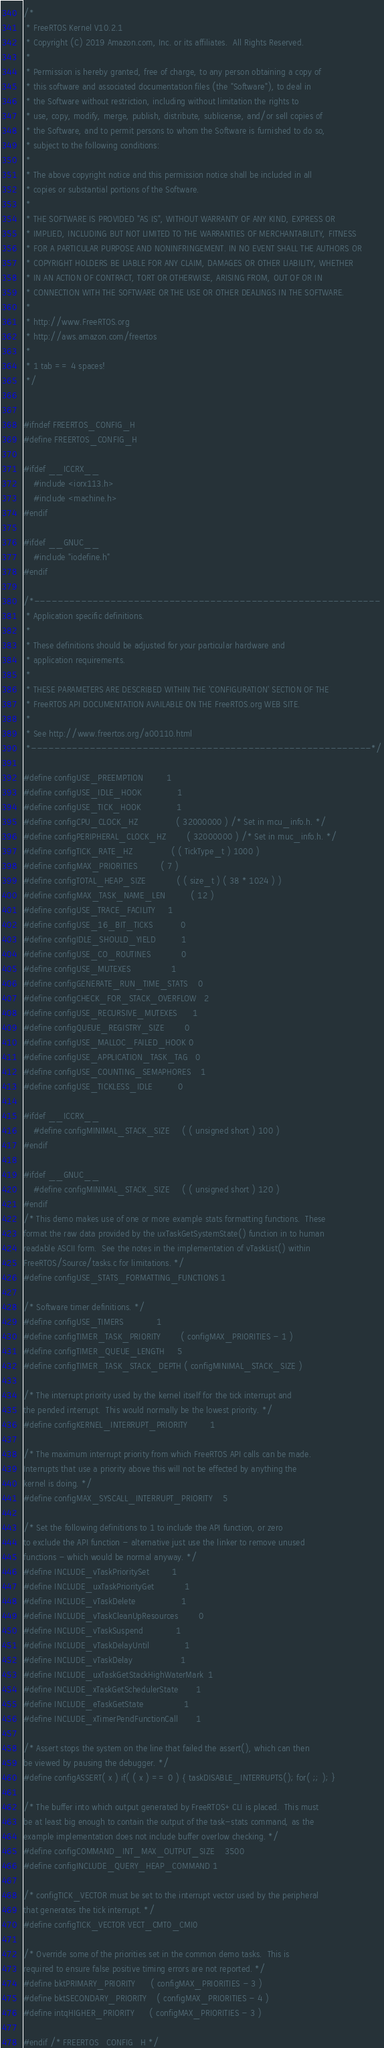<code> <loc_0><loc_0><loc_500><loc_500><_C_>/*
 * FreeRTOS Kernel V10.2.1
 * Copyright (C) 2019 Amazon.com, Inc. or its affiliates.  All Rights Reserved.
 *
 * Permission is hereby granted, free of charge, to any person obtaining a copy of
 * this software and associated documentation files (the "Software"), to deal in
 * the Software without restriction, including without limitation the rights to
 * use, copy, modify, merge, publish, distribute, sublicense, and/or sell copies of
 * the Software, and to permit persons to whom the Software is furnished to do so,
 * subject to the following conditions:
 *
 * The above copyright notice and this permission notice shall be included in all
 * copies or substantial portions of the Software.
 *
 * THE SOFTWARE IS PROVIDED "AS IS", WITHOUT WARRANTY OF ANY KIND, EXPRESS OR
 * IMPLIED, INCLUDING BUT NOT LIMITED TO THE WARRANTIES OF MERCHANTABILITY, FITNESS
 * FOR A PARTICULAR PURPOSE AND NONINFRINGEMENT. IN NO EVENT SHALL THE AUTHORS OR
 * COPYRIGHT HOLDERS BE LIABLE FOR ANY CLAIM, DAMAGES OR OTHER LIABILITY, WHETHER
 * IN AN ACTION OF CONTRACT, TORT OR OTHERWISE, ARISING FROM, OUT OF OR IN
 * CONNECTION WITH THE SOFTWARE OR THE USE OR OTHER DEALINGS IN THE SOFTWARE.
 *
 * http://www.FreeRTOS.org
 * http://aws.amazon.com/freertos
 *
 * 1 tab == 4 spaces!
 */


#ifndef FREERTOS_CONFIG_H
#define FREERTOS_CONFIG_H

#ifdef __ICCRX__
	#include <iorx113.h>
	#include <machine.h>
#endif

#ifdef __GNUC__
	#include "iodefine.h"
#endif

/*-----------------------------------------------------------
 * Application specific definitions.
 *
 * These definitions should be adjusted for your particular hardware and
 * application requirements.
 *
 * THESE PARAMETERS ARE DESCRIBED WITHIN THE 'CONFIGURATION' SECTION OF THE
 * FreeRTOS API DOCUMENTATION AVAILABLE ON THE FreeRTOS.org WEB SITE.
 *
 * See http://www.freertos.org/a00110.html
 *----------------------------------------------------------*/

#define configUSE_PREEMPTION			1
#define configUSE_IDLE_HOOK				1
#define configUSE_TICK_HOOK				1
#define configCPU_CLOCK_HZ				( 32000000 ) /* Set in mcu_info.h. */
#define configPERIPHERAL_CLOCK_HZ		( 32000000 ) /* Set in muc_info.h. */
#define configTICK_RATE_HZ				( ( TickType_t ) 1000 )
#define configMAX_PRIORITIES			( 7 )
#define configTOTAL_HEAP_SIZE			( ( size_t ) ( 38 * 1024 ) )
#define configMAX_TASK_NAME_LEN			( 12 )
#define configUSE_TRACE_FACILITY		1
#define configUSE_16_BIT_TICKS			0
#define configIDLE_SHOULD_YIELD			1
#define configUSE_CO_ROUTINES 			0
#define configUSE_MUTEXES				1
#define configGENERATE_RUN_TIME_STATS	0
#define configCHECK_FOR_STACK_OVERFLOW	2
#define configUSE_RECURSIVE_MUTEXES		1
#define configQUEUE_REGISTRY_SIZE		0
#define configUSE_MALLOC_FAILED_HOOK	0
#define configUSE_APPLICATION_TASK_TAG	0
#define configUSE_COUNTING_SEMAPHORES	1
#define configUSE_TICKLESS_IDLE			0

#ifdef __ICCRX__
	#define configMINIMAL_STACK_SIZE		( ( unsigned short ) 100 )
#endif

#ifdef __GNUC__
	#define configMINIMAL_STACK_SIZE		( ( unsigned short ) 120 )
#endif
/* This demo makes use of one or more example stats formatting functions.  These
format the raw data provided by the uxTaskGetSystemState() function in to human
readable ASCII form.  See the notes in the implementation of vTaskList() within
FreeRTOS/Source/tasks.c for limitations. */
#define configUSE_STATS_FORMATTING_FUNCTIONS	1

/* Software timer definitions. */
#define configUSE_TIMERS				1
#define configTIMER_TASK_PRIORITY		( configMAX_PRIORITIES - 1 )
#define configTIMER_QUEUE_LENGTH		5
#define configTIMER_TASK_STACK_DEPTH	( configMINIMAL_STACK_SIZE )

/* The interrupt priority used by the kernel itself for the tick interrupt and
the pended interrupt.  This would normally be the lowest priority. */
#define configKERNEL_INTERRUPT_PRIORITY         1

/* The maximum interrupt priority from which FreeRTOS API calls can be made.
Interrupts that use a priority above this will not be effected by anything the
kernel is doing. */
#define configMAX_SYSCALL_INTERRUPT_PRIORITY    5

/* Set the following definitions to 1 to include the API function, or zero
to exclude the API function - alternative just use the linker to remove unused
functions - which would be normal anyway. */
#define INCLUDE_vTaskPrioritySet			1
#define INCLUDE_uxTaskPriorityGet			1
#define INCLUDE_vTaskDelete					1
#define INCLUDE_vTaskCleanUpResources		0
#define INCLUDE_vTaskSuspend				1
#define INCLUDE_vTaskDelayUntil				1
#define INCLUDE_vTaskDelay					1
#define INCLUDE_uxTaskGetStackHighWaterMark	1
#define INCLUDE_xTaskGetSchedulerState		1
#define INCLUDE_eTaskGetState				1
#define INCLUDE_xTimerPendFunctionCall		1

/* Assert stops the system on the line that failed the assert(), which can then
be viewed by pausing the debugger. */
#define configASSERT( x ) if( ( x ) == 0 ) { taskDISABLE_INTERRUPTS(); for( ;; ); }

/* The buffer into which output generated by FreeRTOS+CLI is placed.  This must
be at least big enough to contain the output of the task-stats command, as the
example implementation does not include buffer overlow checking. */
#define configCOMMAND_INT_MAX_OUTPUT_SIZE	3500
#define configINCLUDE_QUERY_HEAP_COMMAND	1

/* configTICK_VECTOR must be set to the interrupt vector used by the peripheral
that generates the tick interrupt. */
#define configTICK_VECTOR VECT_CMT0_CMI0

/* Override some of the priorities set in the common demo tasks.  This is
required to ensure false positive timing errors are not reported. */
#define bktPRIMARY_PRIORITY		( configMAX_PRIORITIES - 3 )
#define bktSECONDARY_PRIORITY	( configMAX_PRIORITIES - 4 )
#define intqHIGHER_PRIORITY		( configMAX_PRIORITIES - 3 )

#endif /* FREERTOS_CONFIG_H */
</code> 